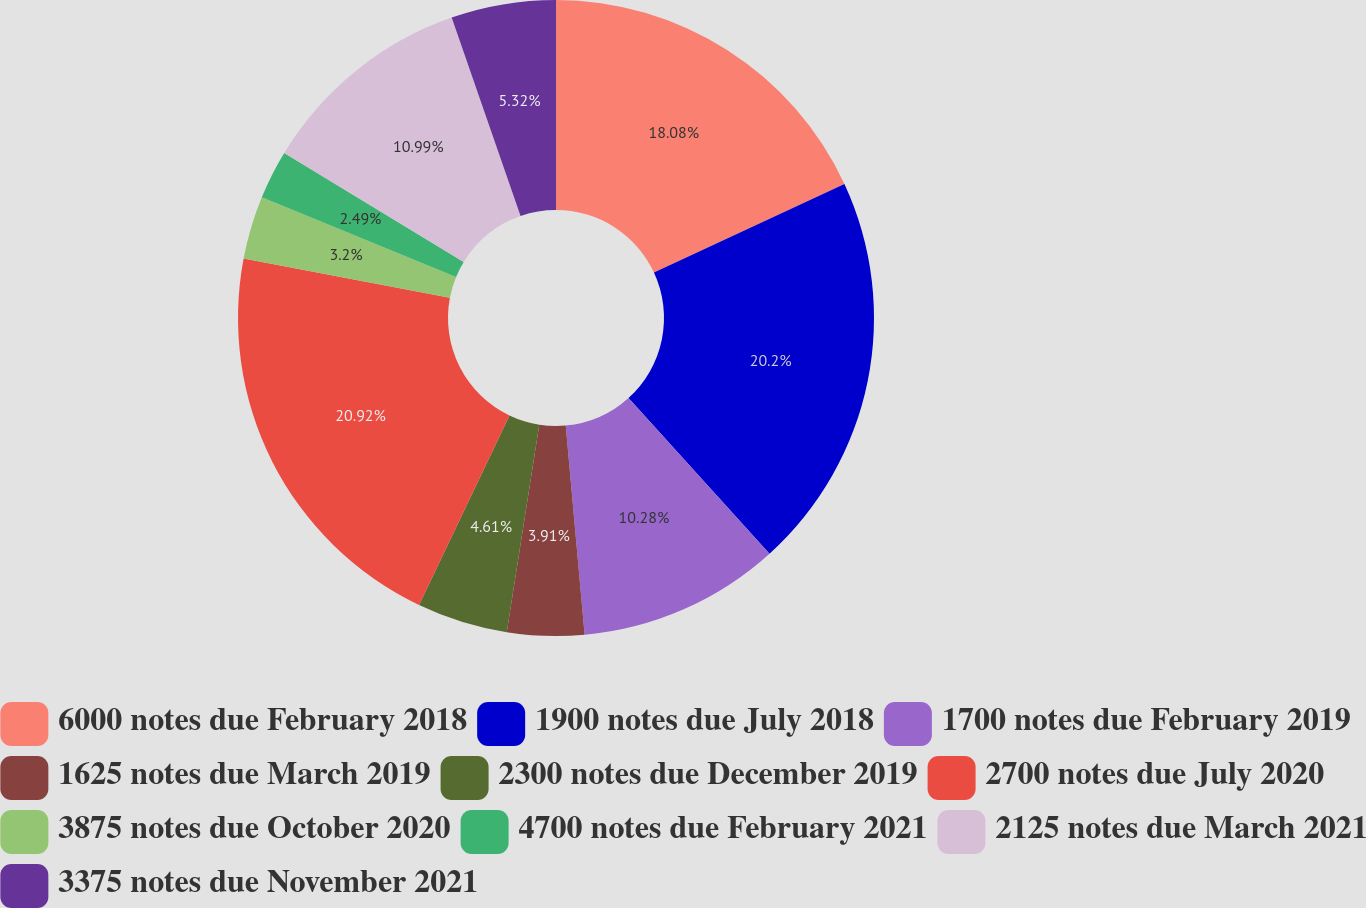Convert chart. <chart><loc_0><loc_0><loc_500><loc_500><pie_chart><fcel>6000 notes due February 2018<fcel>1900 notes due July 2018<fcel>1700 notes due February 2019<fcel>1625 notes due March 2019<fcel>2300 notes due December 2019<fcel>2700 notes due July 2020<fcel>3875 notes due October 2020<fcel>4700 notes due February 2021<fcel>2125 notes due March 2021<fcel>3375 notes due November 2021<nl><fcel>18.08%<fcel>20.2%<fcel>10.28%<fcel>3.91%<fcel>4.61%<fcel>20.91%<fcel>3.2%<fcel>2.49%<fcel>10.99%<fcel>5.32%<nl></chart> 